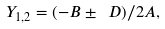Convert formula to latex. <formula><loc_0><loc_0><loc_500><loc_500>Y _ { 1 , 2 } = ( - B \pm \ D ) / 2 A ,</formula> 